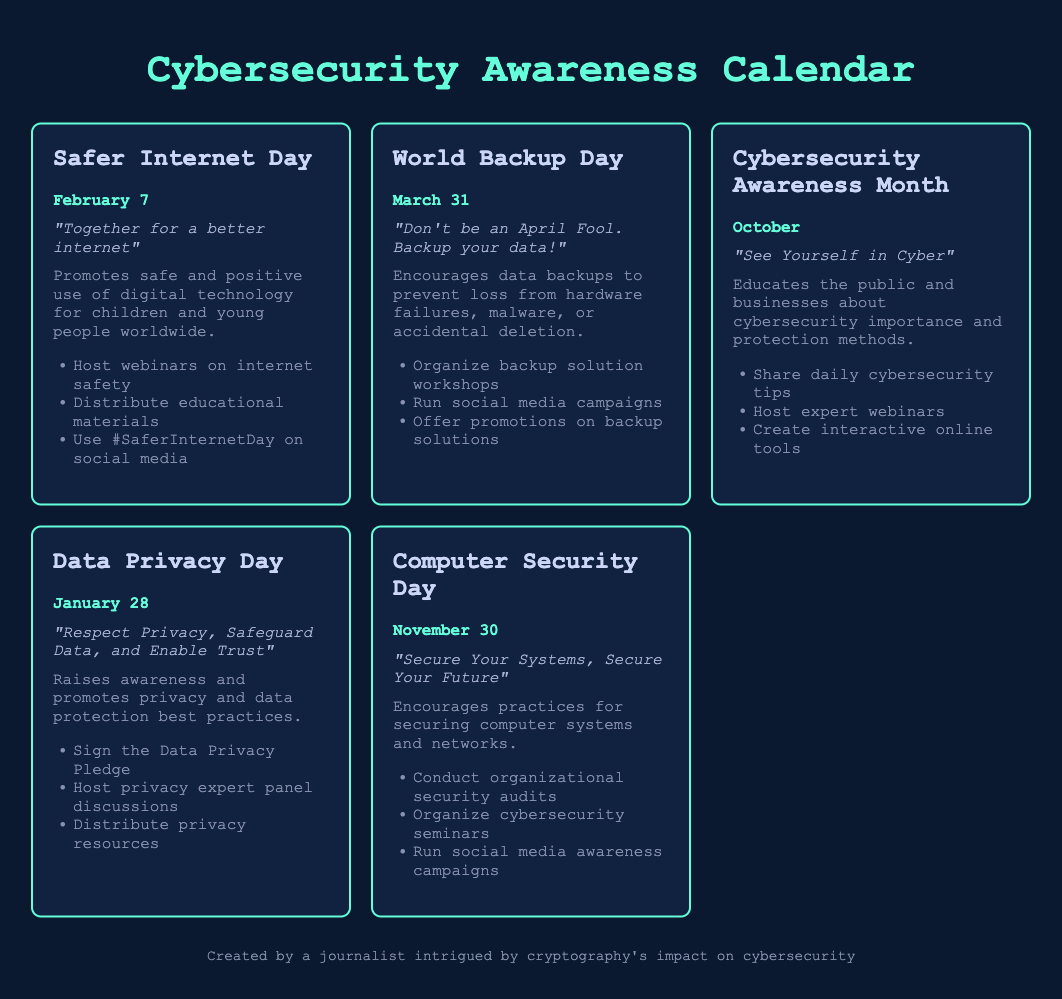What is the date of Safer Internet Day? The date of Safer Internet Day is explicitly mentioned in the document as February 7.
Answer: February 7 What is the theme for World Backup Day? The theme for World Backup Day is provided in the document as "Don't be an April Fool. Backup your data!".
Answer: "Don't be an April Fool. Backup your data!" Which month is designated for Cybersecurity Awareness Month? The document explicitly states that Cybersecurity Awareness Month occurs in October.
Answer: October What type of events does Data Privacy Day promote? Data Privacy Day promotes awareness and best practices for privacy and data protection, as stated in the document.
Answer: Privacy and data protection What is the main focus of Computer Security Day? The main focus of Computer Security Day is to encourage practices for securing computer systems and networks.
Answer: Securing computer systems How many events are listed in the document? The document lists five distinct events related to cybersecurity awareness.
Answer: Five What action can participants take during Safer Internet Day? Participants can host webinars on internet safety, which is one of the suggested actions in the document.
Answer: Host webinars on internet safety What is a recommended activity for Cybersecurity Awareness Month? A suggested activity for Cybersecurity Awareness Month is to share daily cybersecurity tips as mentioned in the document.
Answer: Share daily cybersecurity tips What color scheme is used in the calendar document? The color scheme includes dark blue, neon green, and gray, as described in the styling section of the document.
Answer: Dark blue, neon green, and gray 